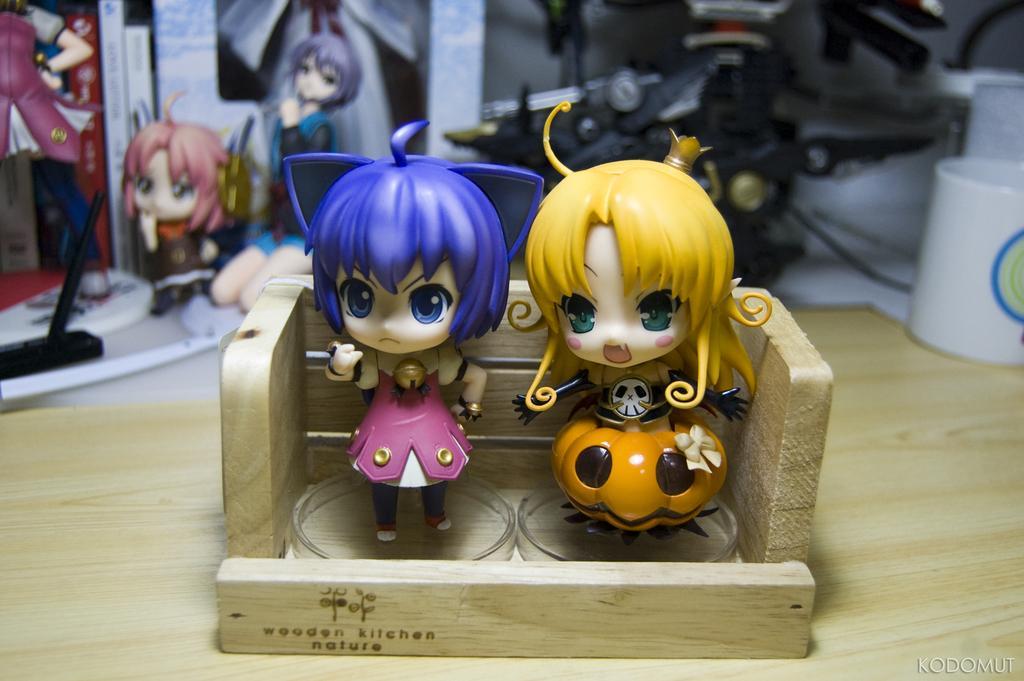Could you give a brief overview of what you see in this image? In this picture, there are two toys in the wooden board. One toy is in pink and blue in color. Another toy is in yellow in color. On the top, there is a device. Towards the right, there is a cup. On the top left, there are toys. 